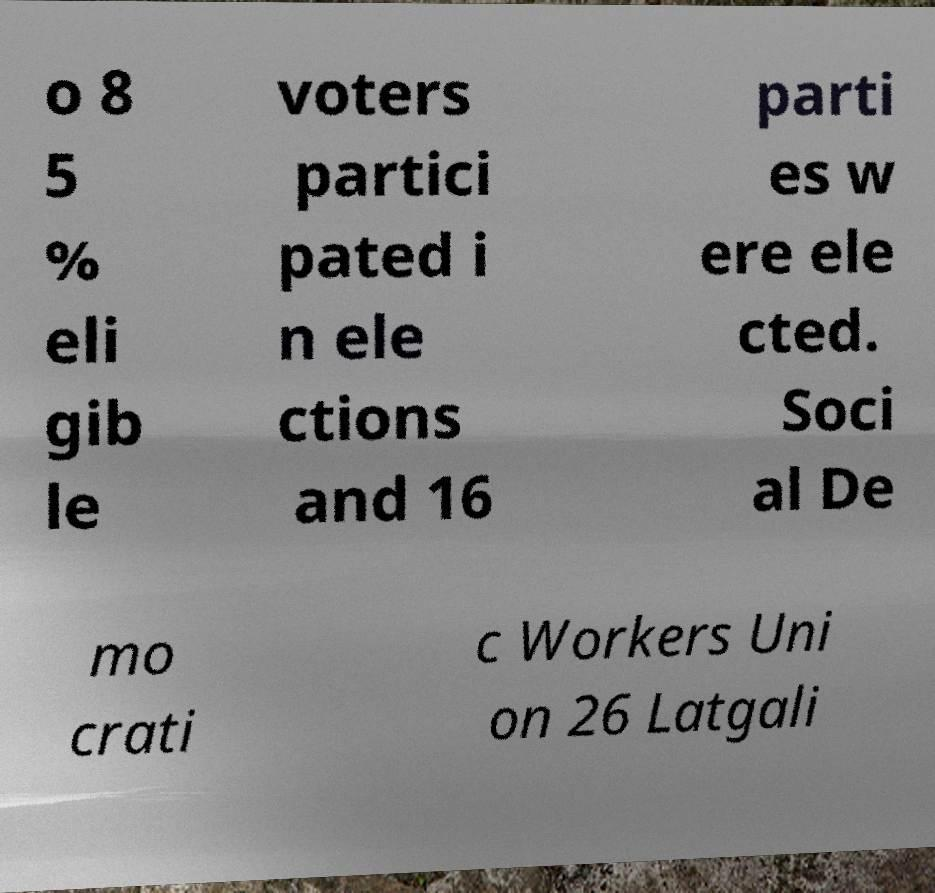There's text embedded in this image that I need extracted. Can you transcribe it verbatim? o 8 5 % eli gib le voters partici pated i n ele ctions and 16 parti es w ere ele cted. Soci al De mo crati c Workers Uni on 26 Latgali 